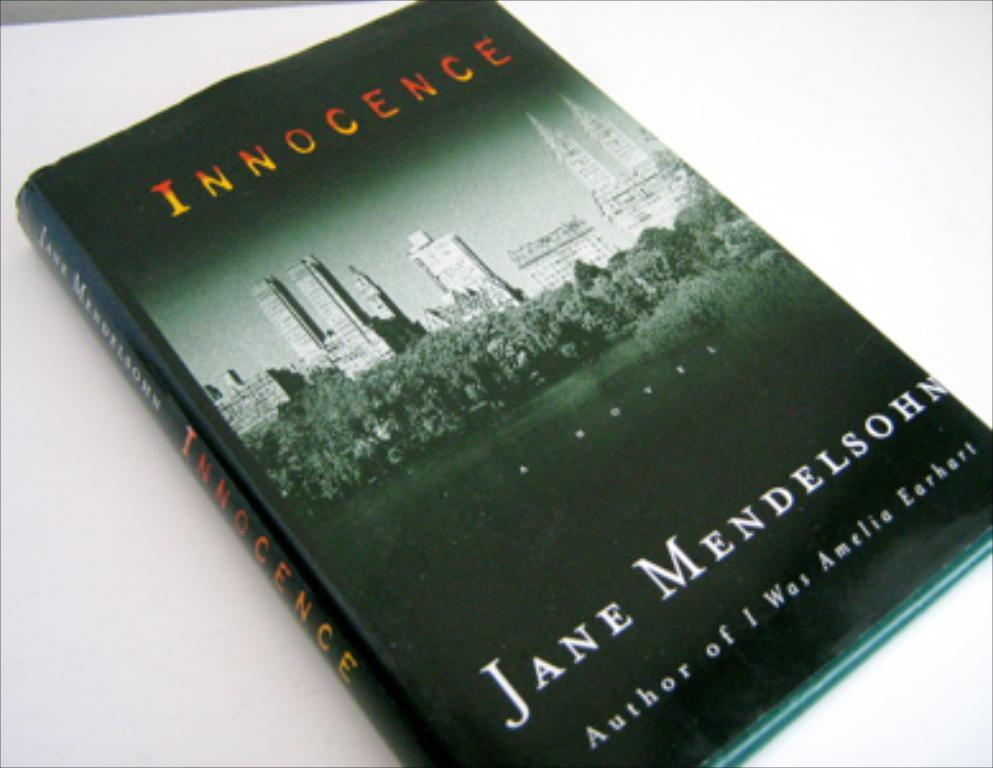Provide a one-sentence caption for the provided image. A cover for the book Innocence written by Jane Mendelsohn. 